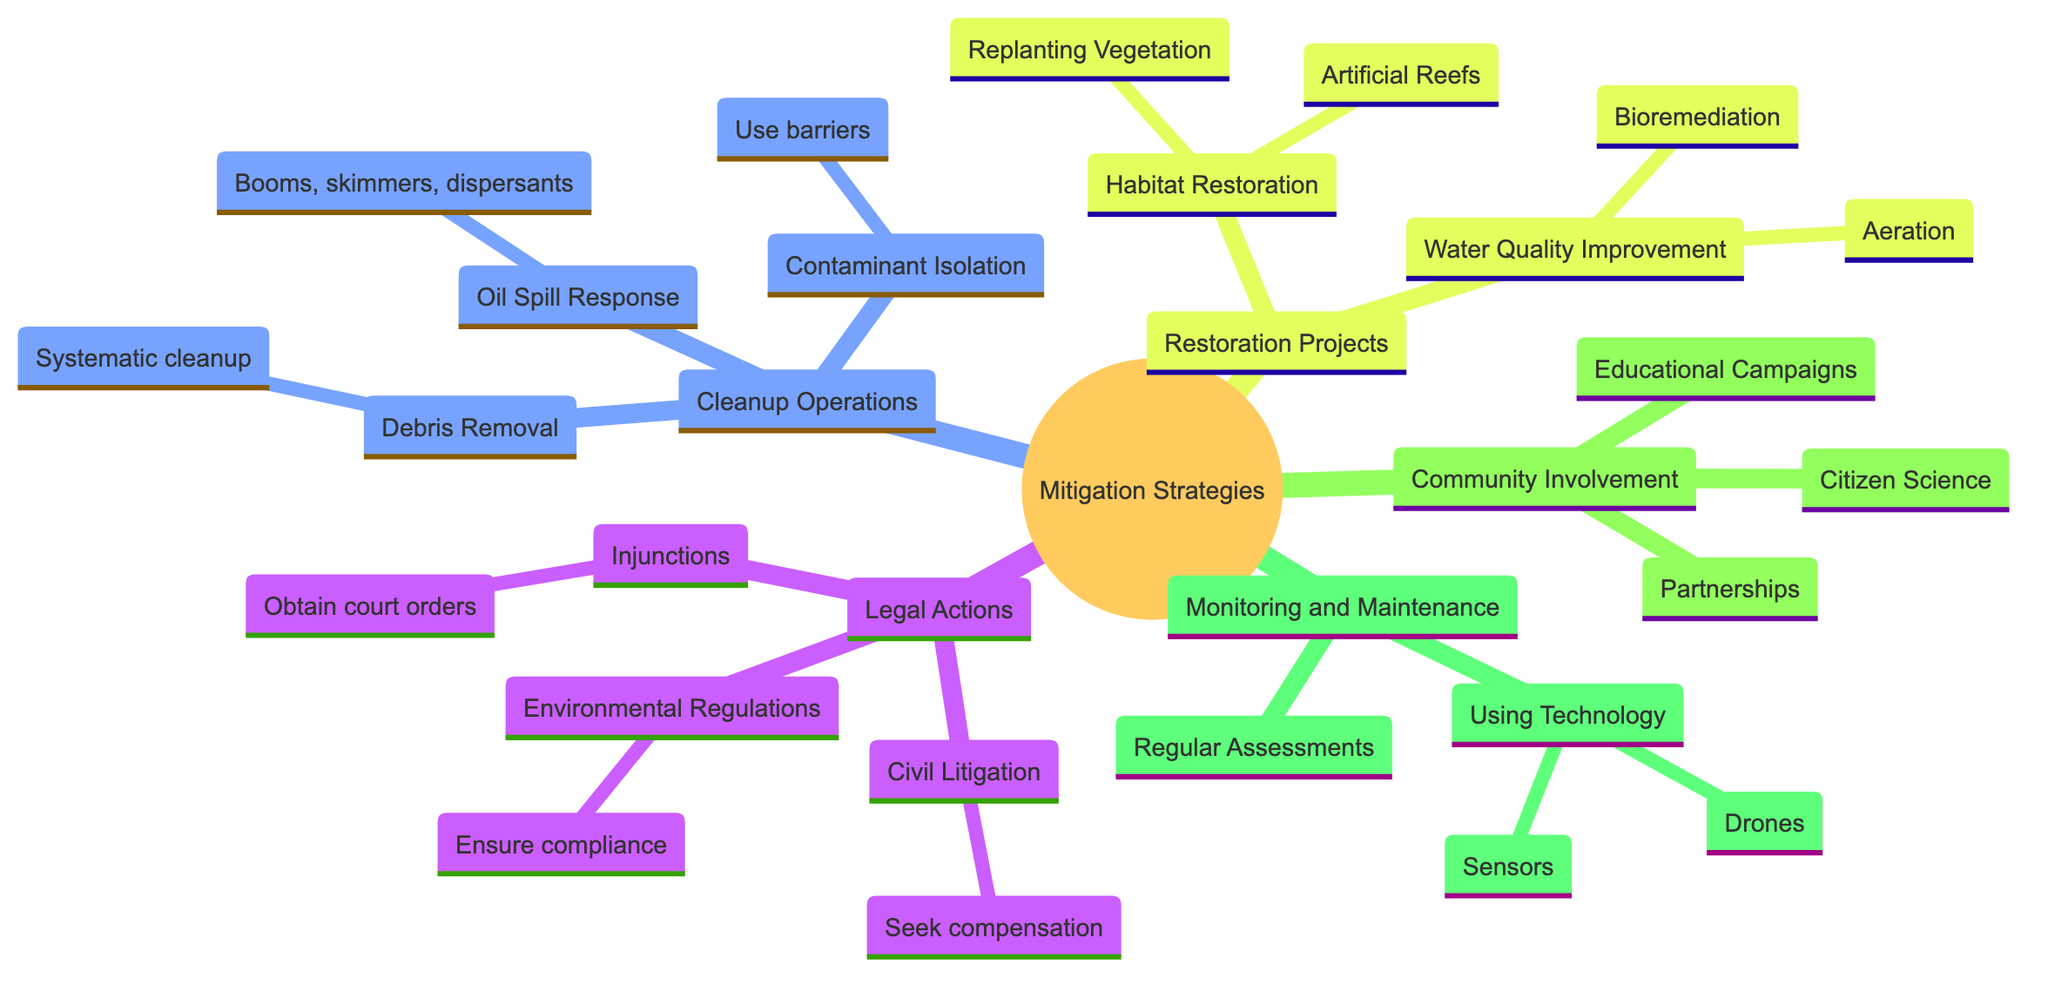What are the three main categories of mitigation strategies? The diagram has a root node titled "Mitigation Strategies for Environmental Restoration," which branches into five main categories: Legal Actions, Cleanup Operations, Restoration Projects, Community Involvement, and Monitoring and Maintenance.
Answer: Legal Actions, Cleanup Operations, Restoration Projects, Community Involvement, Monitoring and Maintenance How many types of Legal Actions are listed? Under the "Legal Actions" category, there are three types: Civil Litigation, Environmental Regulations, and Injunctions. This can be counted directly from the diagram.
Answer: 3 What technique is mentioned for oil spill response? The "Oil Spill Response" node in the "Cleanup Operations" category lists specific techniques, including booms, skimmers, and dispersants. Since the question asks for any technique mentioned, I can choose any of them, but the first one listed is a valid answer.
Answer: Booms What two strategies are suggested for improving water quality? In the "Water Quality Improvement" section under "Restoration Projects," there are two strategies mentioned: Aeration and Bioremediation. I check the nodes under this category to confirm both are present.
Answer: Aeration, Bioremediation What is one action that can be taken under Community Involvement? The "Community Involvement" category suggests three actions, one of which is "Educational Campaigns." This is listed as a way to engage the community and raise awareness.
Answer: Educational Campaigns How many different types of restoration projects are outlined? The "Restoration Projects" section has two main subcategories: Habitat Restoration and Water Quality Improvement. Each of these represents a different type of restoration project, thus there are two types.
Answer: 2 What technology is suggested for monitoring affected areas? In the "Using Technology" subsection under "Monitoring and Maintenance," two specific technologies are mentioned: Drones and Sensors. I can confidently state either since the question asks for any technology mentioned.
Answer: Drones What kind of campaigns can be initiated to involve the community? Within the "Community Involvement" category, one of the strategies listed is "Educational Campaigns," which aims to raise awareness about environmental protection. This can be answered by quoting directly from the diagram.
Answer: Educational Campaigns How can contaminants be isolated according to the diagram? The "Contaminant Isolation" node under "Cleanup Operations" states that barriers should be used to prevent the spread of pollutants. This directly indicates the method for isolating contaminants.
Answer: Use barriers 